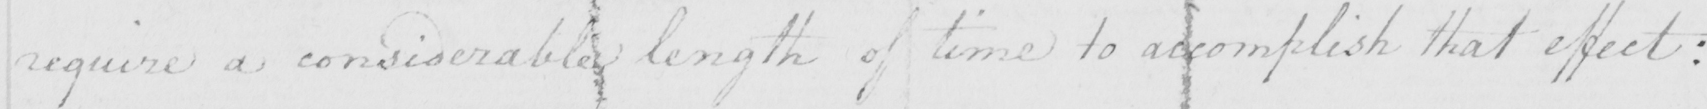What is written in this line of handwriting? require a considerable length of time to accomplish that effect : 